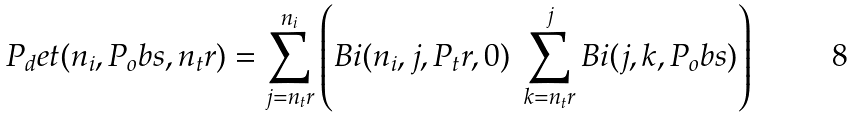Convert formula to latex. <formula><loc_0><loc_0><loc_500><loc_500>P _ { d } e t ( n _ { i } , P _ { o } b s , n _ { t } r ) = \sum _ { j = n _ { t } r } ^ { n _ { i } } \left ( B i ( n _ { i } , j , P _ { t } r , 0 ) \ \sum _ { k = n _ { t } r } ^ { j } B i ( j , k , P _ { o } b s ) \right )</formula> 